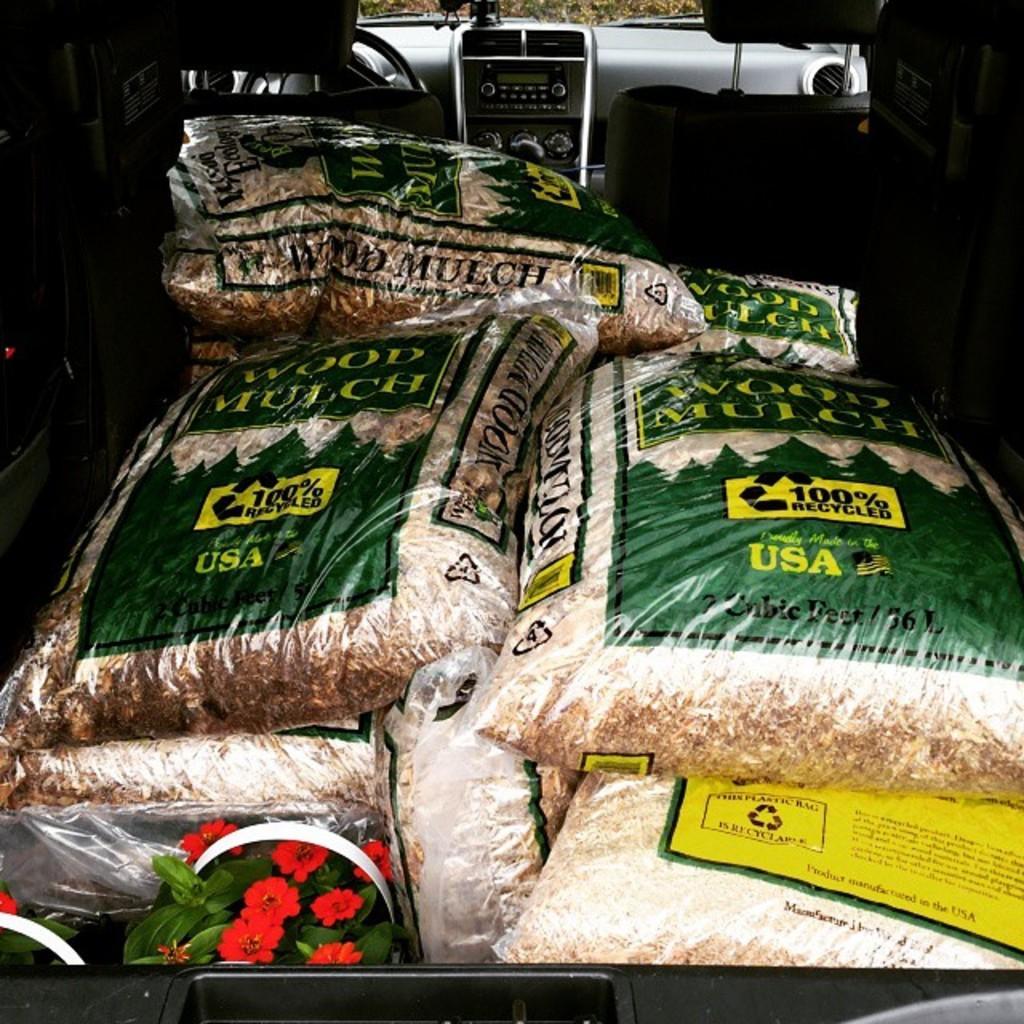Please provide a concise description of this image. In this image there are bags, flower pots in the vehicle. 